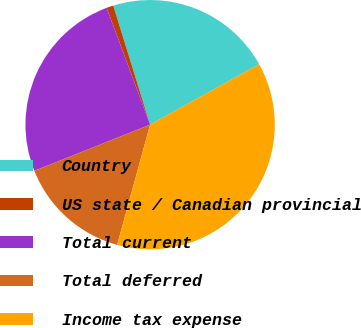Convert chart. <chart><loc_0><loc_0><loc_500><loc_500><pie_chart><fcel>Country<fcel>US state / Canadian provincial<fcel>Total current<fcel>Total deferred<fcel>Income tax expense<nl><fcel>21.72%<fcel>0.89%<fcel>25.37%<fcel>14.7%<fcel>37.32%<nl></chart> 